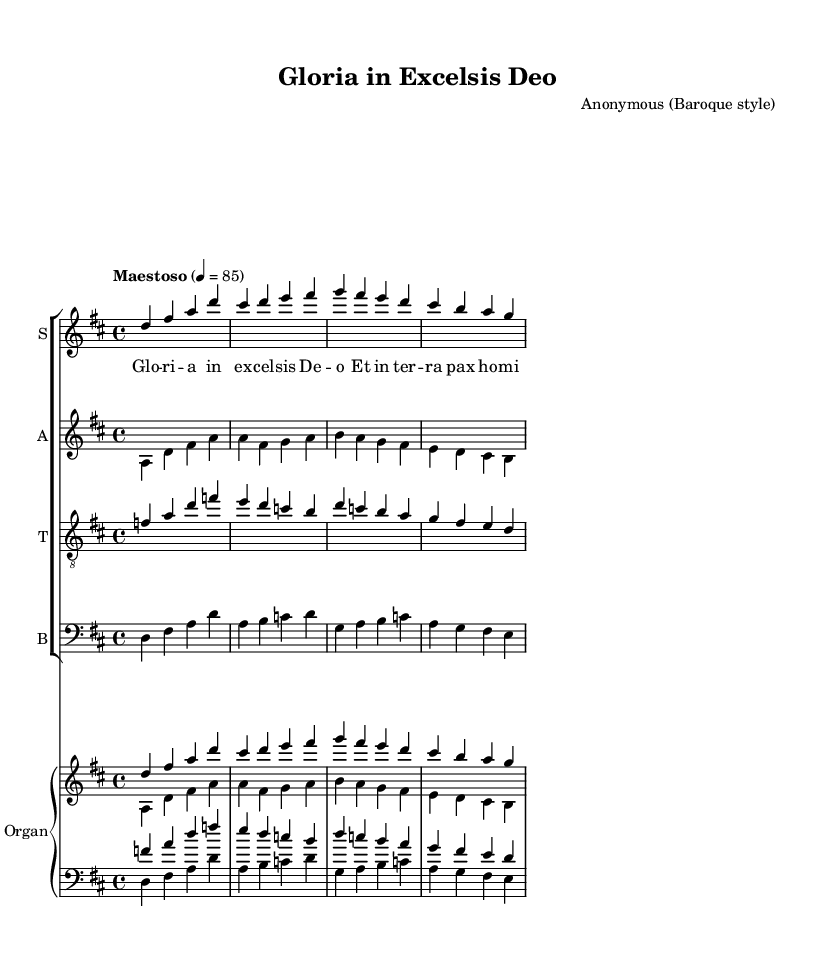What is the key signature of this music? The key signature displayed in the music shows two sharps, corresponding to the notes F# and C#. This indicates that the piece is in D major.
Answer: D major What is the time signature? The time signature indicated at the beginning of the score shows a "4/4" notation, meaning there are four beats per measure and the quarter note receives one beat.
Answer: 4/4 What is the tempo marking for this piece? The tempo marking above the staff indicates "Maestoso," which suggests a dignified and stately tempo. The metronome marking of "4=85" indicates a specific speed for the quarter note.
Answer: Maestoso How many vocal parts are arranged in this piece? By observing the score, there are four distinct vocal parts indicated: Soprano, Alto, Tenor, and Bass, which corresponds to a typical choral arrangement.
Answer: Four Which voice section has the lowest range? The bass section is indicated at the lowest staff position and uses the bass clef, showing it has the lowest pitches among the vocal parts.
Answer: Bass What is the style of the composer of this piece? The score is attributed to an anonymous composer in the style of the Baroque period, which is characterized by elaborate musical ornamentation and expressive melodies.
Answer: Baroque 